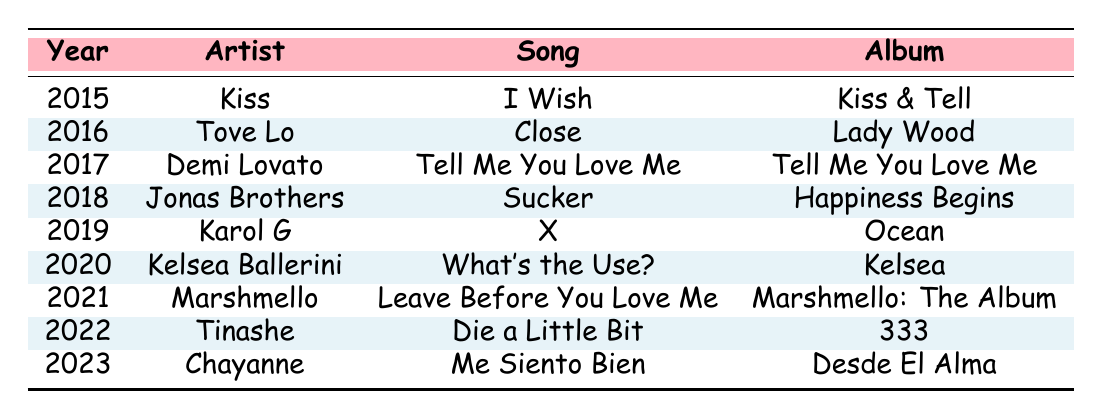What song did Nick Jonas collaborate on in 2017? According to the table, in 2017, Nick Jonas collaborated with Demi Lovato on the song "Tell Me You Love Me."
Answer: Tell Me You Love Me Which artist did Nick Jonas collaborate with in 2019? In 2019, Nick Jonas collaborated with artist Karol G.
Answer: Karol G How many collaborations did Nick Jonas have from 2015 to 2023? The table lists 9 collaborations between 2015 and 2023, one for each year mentioned.
Answer: 9 What is the title of the song Nick Jonas worked on with Chayanne in 2023? The collaboration with Chayanne in 2023 is titled "Me Siento Bien."
Answer: Me Siento Bien In which year did Nick Jonas collaborate with the Jonas Brothers? The collaboration with the Jonas Brothers occurred in 2018.
Answer: 2018 Did Nick Jonas collaborate with Tinashe? Yes, he collaborated with Tinashe in 2022.
Answer: Yes What is the average year of Nick Jonas's collaborations based on the data? The years of collaboration are 2015, 2016, 2017, 2018, 2019, 2020, 2021, 2022, and 2023, which sum to 1815. There are 9 years, so the average is 1815/9 = 201.67. Rounding gives the average year as approximately 2019.
Answer: Approximately 2019 Which collaboration happened most recently? The table shows that the most recent collaboration is with Chayanne in 2023.
Answer: Chayanne in 2023 How many collaborations feature the title "Tell Me You Love Me"? According to the table, the song "Tell Me You Love Me" appears once, in 2017 with Demi Lovato.
Answer: 1 What is the title of the song from Nick Jonas's collaboration with Karol G? The song collaborated with Karol G in 2019 is titled "X."
Answer: X 